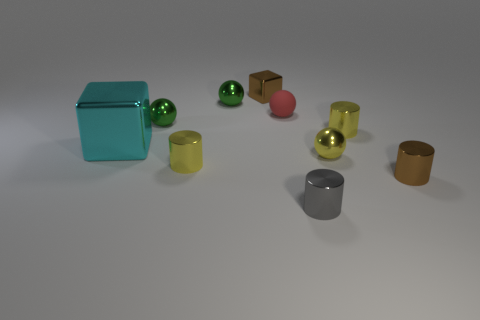What number of objects are the same size as the yellow metallic sphere?
Offer a very short reply. 8. There is a metal object right of the tiny yellow cylinder that is to the right of the red thing; what is its size?
Provide a short and direct response. Small. Do the tiny brown object that is right of the tiny gray shiny cylinder and the small yellow metallic thing left of the red ball have the same shape?
Offer a very short reply. Yes. What color is the tiny metallic object that is both in front of the cyan shiny cube and left of the red matte ball?
Provide a succinct answer. Yellow. Is there a thing of the same color as the tiny cube?
Your answer should be compact. Yes. The small metallic cylinder behind the big object is what color?
Your answer should be compact. Yellow. There is a yellow cylinder to the right of the small gray metallic cylinder; is there a small green object behind it?
Keep it short and to the point. Yes. Are there any small spheres that have the same material as the large cyan object?
Keep it short and to the point. Yes. What number of small spheres are there?
Provide a succinct answer. 4. There is a small brown thing that is in front of the tiny metallic cylinder to the left of the tiny brown metallic cube; what is its material?
Offer a very short reply. Metal. 